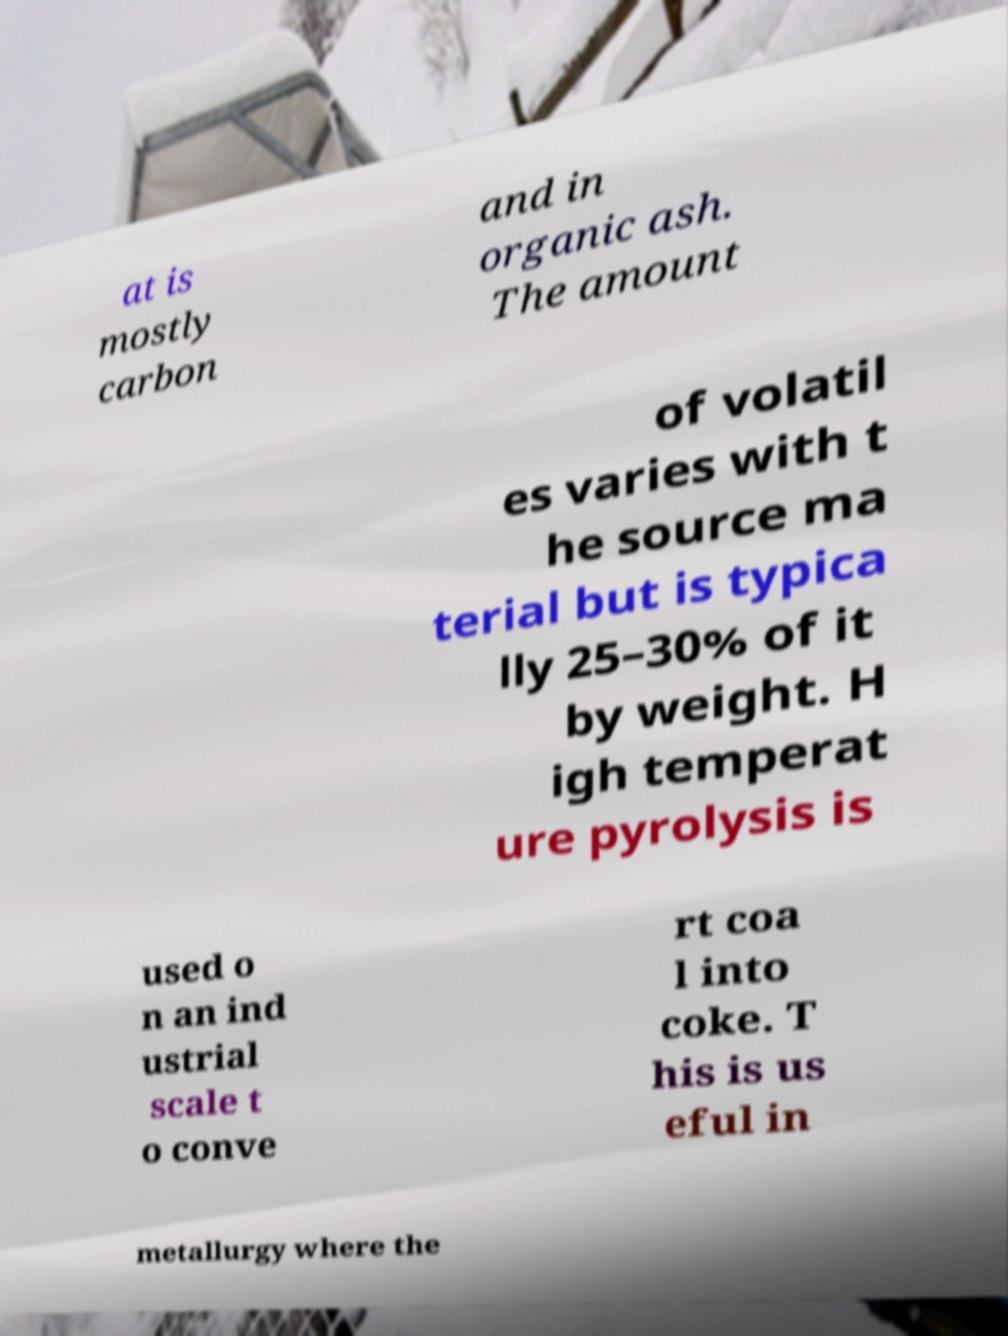Please read and relay the text visible in this image. What does it say? at is mostly carbon and in organic ash. The amount of volatil es varies with t he source ma terial but is typica lly 25–30% of it by weight. H igh temperat ure pyrolysis is used o n an ind ustrial scale t o conve rt coa l into coke. T his is us eful in metallurgy where the 